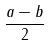Convert formula to latex. <formula><loc_0><loc_0><loc_500><loc_500>\frac { a - b } { 2 }</formula> 